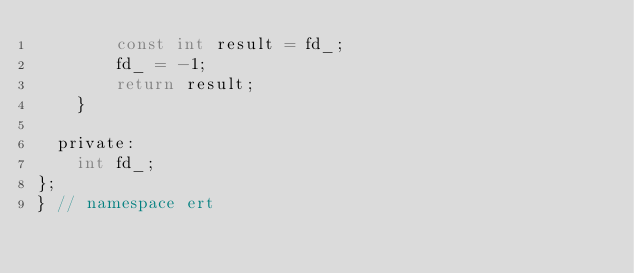<code> <loc_0><loc_0><loc_500><loc_500><_C_>        const int result = fd_;
        fd_ = -1;
        return result;
    }

  private:
    int fd_;
};
} // namespace ert
</code> 